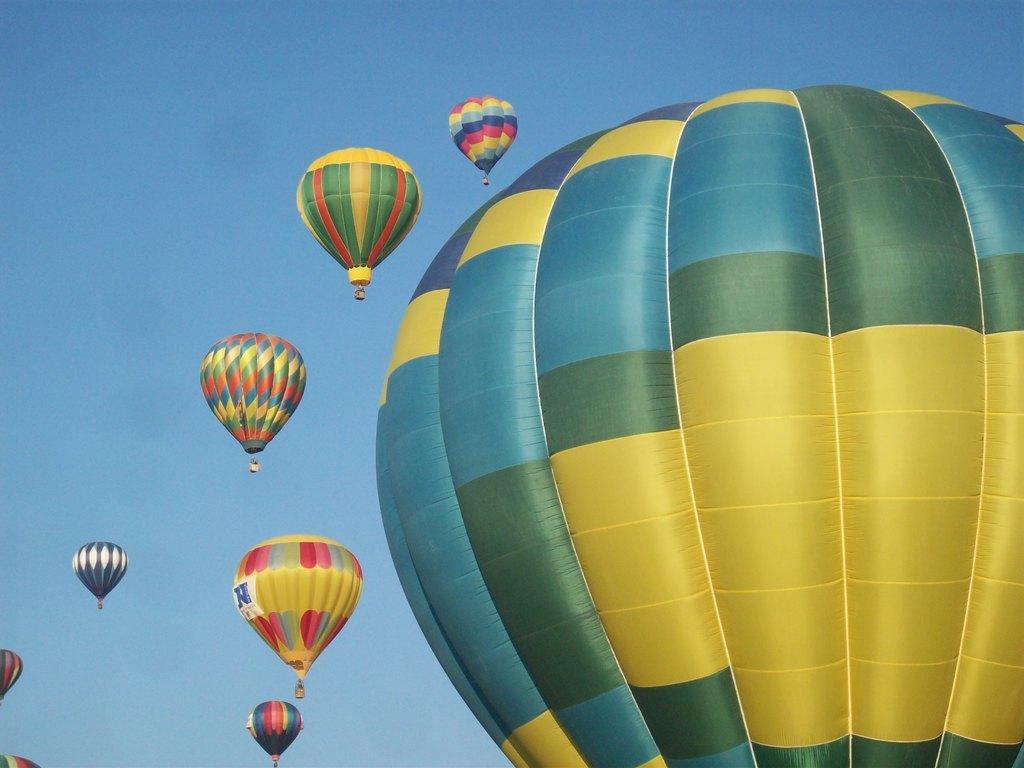Describe this image in one or two sentences. In the picture we can see a huge parachute with yellow, green and blue in color and besides, we can see some parachutes are flying with different colors and in the background we can see a sky which is blue in color. 